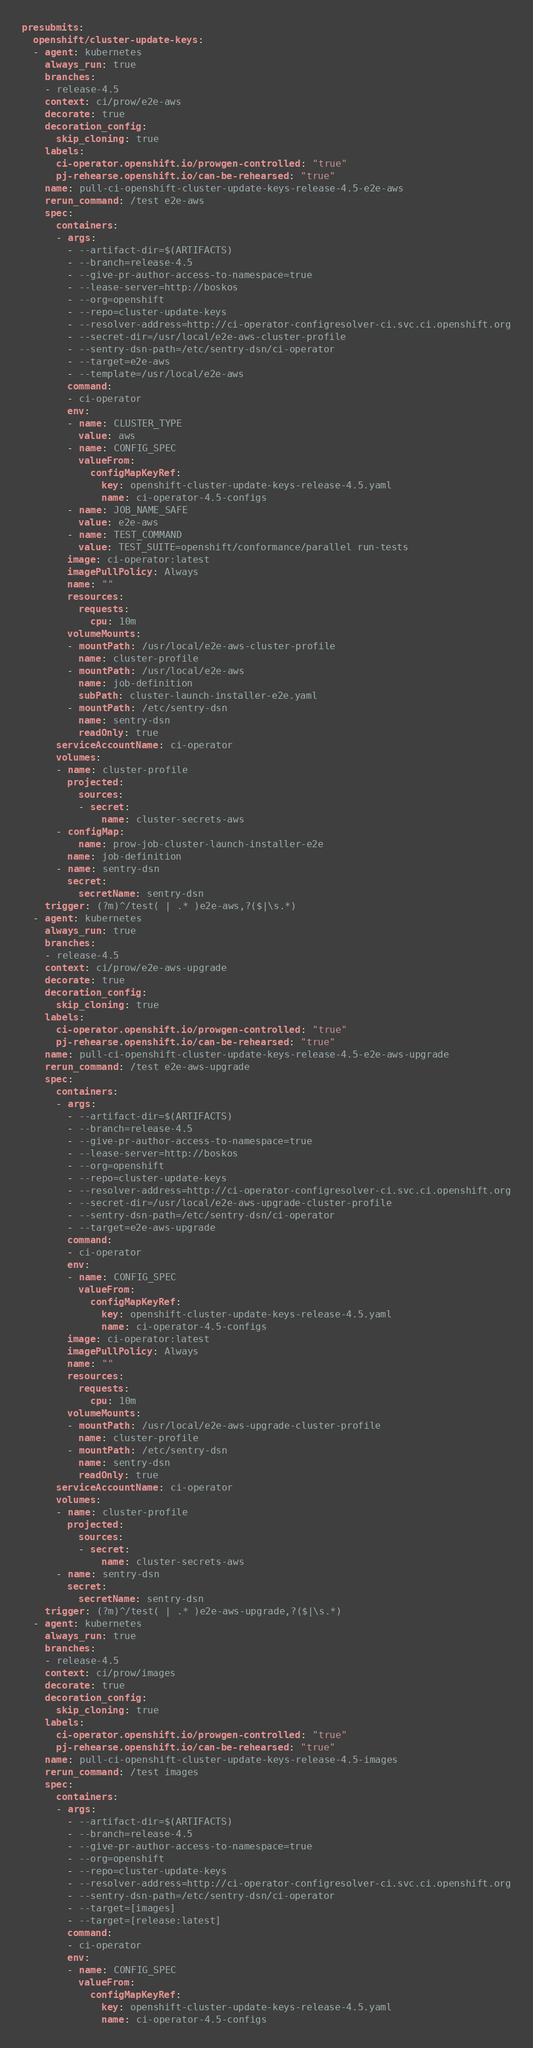Convert code to text. <code><loc_0><loc_0><loc_500><loc_500><_YAML_>presubmits:
  openshift/cluster-update-keys:
  - agent: kubernetes
    always_run: true
    branches:
    - release-4.5
    context: ci/prow/e2e-aws
    decorate: true
    decoration_config:
      skip_cloning: true
    labels:
      ci-operator.openshift.io/prowgen-controlled: "true"
      pj-rehearse.openshift.io/can-be-rehearsed: "true"
    name: pull-ci-openshift-cluster-update-keys-release-4.5-e2e-aws
    rerun_command: /test e2e-aws
    spec:
      containers:
      - args:
        - --artifact-dir=$(ARTIFACTS)
        - --branch=release-4.5
        - --give-pr-author-access-to-namespace=true
        - --lease-server=http://boskos
        - --org=openshift
        - --repo=cluster-update-keys
        - --resolver-address=http://ci-operator-configresolver-ci.svc.ci.openshift.org
        - --secret-dir=/usr/local/e2e-aws-cluster-profile
        - --sentry-dsn-path=/etc/sentry-dsn/ci-operator
        - --target=e2e-aws
        - --template=/usr/local/e2e-aws
        command:
        - ci-operator
        env:
        - name: CLUSTER_TYPE
          value: aws
        - name: CONFIG_SPEC
          valueFrom:
            configMapKeyRef:
              key: openshift-cluster-update-keys-release-4.5.yaml
              name: ci-operator-4.5-configs
        - name: JOB_NAME_SAFE
          value: e2e-aws
        - name: TEST_COMMAND
          value: TEST_SUITE=openshift/conformance/parallel run-tests
        image: ci-operator:latest
        imagePullPolicy: Always
        name: ""
        resources:
          requests:
            cpu: 10m
        volumeMounts:
        - mountPath: /usr/local/e2e-aws-cluster-profile
          name: cluster-profile
        - mountPath: /usr/local/e2e-aws
          name: job-definition
          subPath: cluster-launch-installer-e2e.yaml
        - mountPath: /etc/sentry-dsn
          name: sentry-dsn
          readOnly: true
      serviceAccountName: ci-operator
      volumes:
      - name: cluster-profile
        projected:
          sources:
          - secret:
              name: cluster-secrets-aws
      - configMap:
          name: prow-job-cluster-launch-installer-e2e
        name: job-definition
      - name: sentry-dsn
        secret:
          secretName: sentry-dsn
    trigger: (?m)^/test( | .* )e2e-aws,?($|\s.*)
  - agent: kubernetes
    always_run: true
    branches:
    - release-4.5
    context: ci/prow/e2e-aws-upgrade
    decorate: true
    decoration_config:
      skip_cloning: true
    labels:
      ci-operator.openshift.io/prowgen-controlled: "true"
      pj-rehearse.openshift.io/can-be-rehearsed: "true"
    name: pull-ci-openshift-cluster-update-keys-release-4.5-e2e-aws-upgrade
    rerun_command: /test e2e-aws-upgrade
    spec:
      containers:
      - args:
        - --artifact-dir=$(ARTIFACTS)
        - --branch=release-4.5
        - --give-pr-author-access-to-namespace=true
        - --lease-server=http://boskos
        - --org=openshift
        - --repo=cluster-update-keys
        - --resolver-address=http://ci-operator-configresolver-ci.svc.ci.openshift.org
        - --secret-dir=/usr/local/e2e-aws-upgrade-cluster-profile
        - --sentry-dsn-path=/etc/sentry-dsn/ci-operator
        - --target=e2e-aws-upgrade
        command:
        - ci-operator
        env:
        - name: CONFIG_SPEC
          valueFrom:
            configMapKeyRef:
              key: openshift-cluster-update-keys-release-4.5.yaml
              name: ci-operator-4.5-configs
        image: ci-operator:latest
        imagePullPolicy: Always
        name: ""
        resources:
          requests:
            cpu: 10m
        volumeMounts:
        - mountPath: /usr/local/e2e-aws-upgrade-cluster-profile
          name: cluster-profile
        - mountPath: /etc/sentry-dsn
          name: sentry-dsn
          readOnly: true
      serviceAccountName: ci-operator
      volumes:
      - name: cluster-profile
        projected:
          sources:
          - secret:
              name: cluster-secrets-aws
      - name: sentry-dsn
        secret:
          secretName: sentry-dsn
    trigger: (?m)^/test( | .* )e2e-aws-upgrade,?($|\s.*)
  - agent: kubernetes
    always_run: true
    branches:
    - release-4.5
    context: ci/prow/images
    decorate: true
    decoration_config:
      skip_cloning: true
    labels:
      ci-operator.openshift.io/prowgen-controlled: "true"
      pj-rehearse.openshift.io/can-be-rehearsed: "true"
    name: pull-ci-openshift-cluster-update-keys-release-4.5-images
    rerun_command: /test images
    spec:
      containers:
      - args:
        - --artifact-dir=$(ARTIFACTS)
        - --branch=release-4.5
        - --give-pr-author-access-to-namespace=true
        - --org=openshift
        - --repo=cluster-update-keys
        - --resolver-address=http://ci-operator-configresolver-ci.svc.ci.openshift.org
        - --sentry-dsn-path=/etc/sentry-dsn/ci-operator
        - --target=[images]
        - --target=[release:latest]
        command:
        - ci-operator
        env:
        - name: CONFIG_SPEC
          valueFrom:
            configMapKeyRef:
              key: openshift-cluster-update-keys-release-4.5.yaml
              name: ci-operator-4.5-configs</code> 